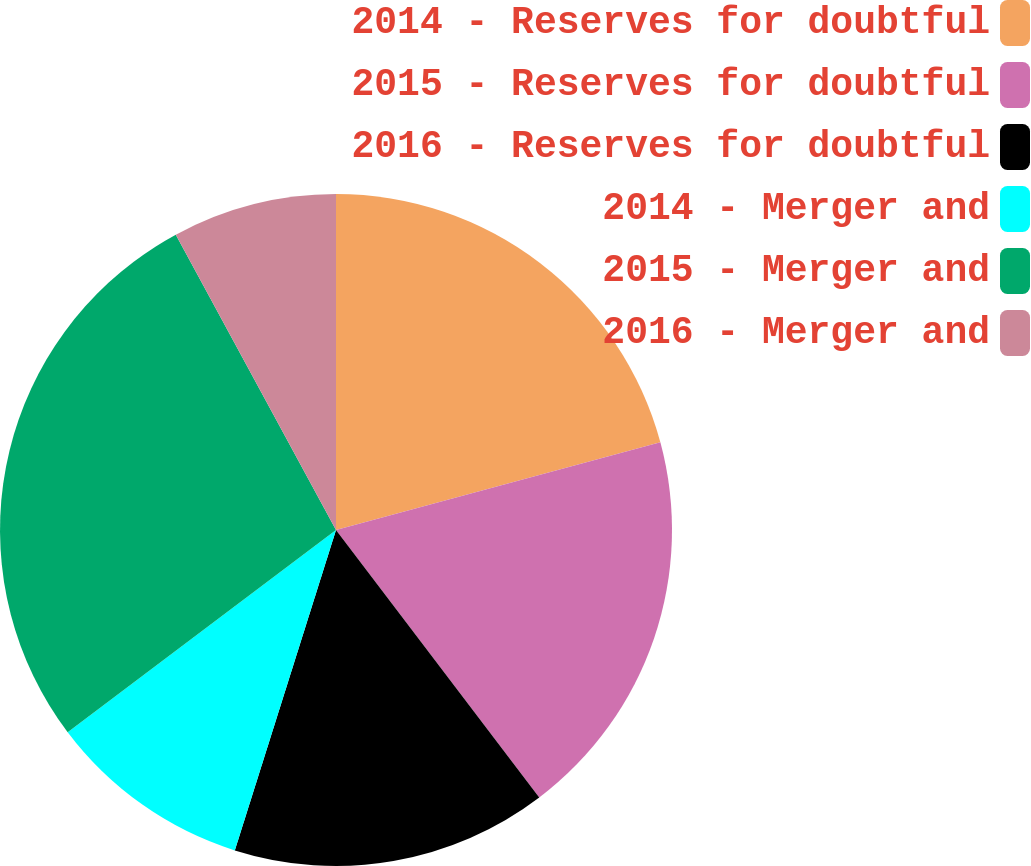Convert chart. <chart><loc_0><loc_0><loc_500><loc_500><pie_chart><fcel>2014 - Reserves for doubtful<fcel>2015 - Reserves for doubtful<fcel>2016 - Reserves for doubtful<fcel>2014 - Merger and<fcel>2015 - Merger and<fcel>2016 - Merger and<nl><fcel>20.8%<fcel>18.86%<fcel>15.21%<fcel>9.85%<fcel>27.37%<fcel>7.91%<nl></chart> 